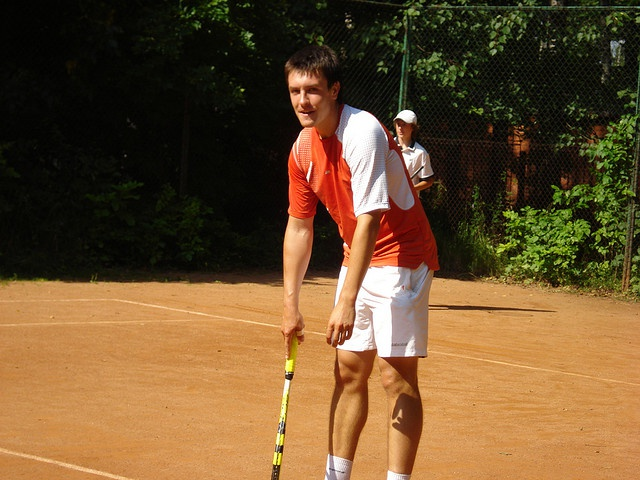Describe the objects in this image and their specific colors. I can see people in black, maroon, white, tan, and brown tones, people in black, white, maroon, and gray tones, tennis racket in black, olive, yellow, ivory, and khaki tones, and tennis racket in black, gray, and lightgray tones in this image. 